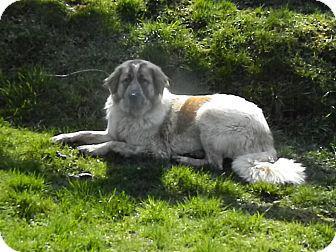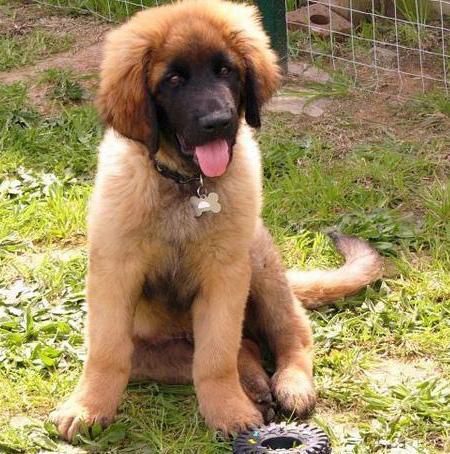The first image is the image on the left, the second image is the image on the right. Examine the images to the left and right. Is the description "One of the dogs has its belly on the ground." accurate? Answer yes or no. Yes. 